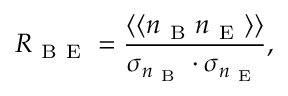Convert formula to latex. <formula><loc_0><loc_0><loc_500><loc_500>R _ { B E } = \frac { \left \langle \langle n _ { B } n _ { E } \right \rangle \rangle } { \sigma _ { n _ { B } } \cdot \sigma _ { n _ { E } } } ,</formula> 